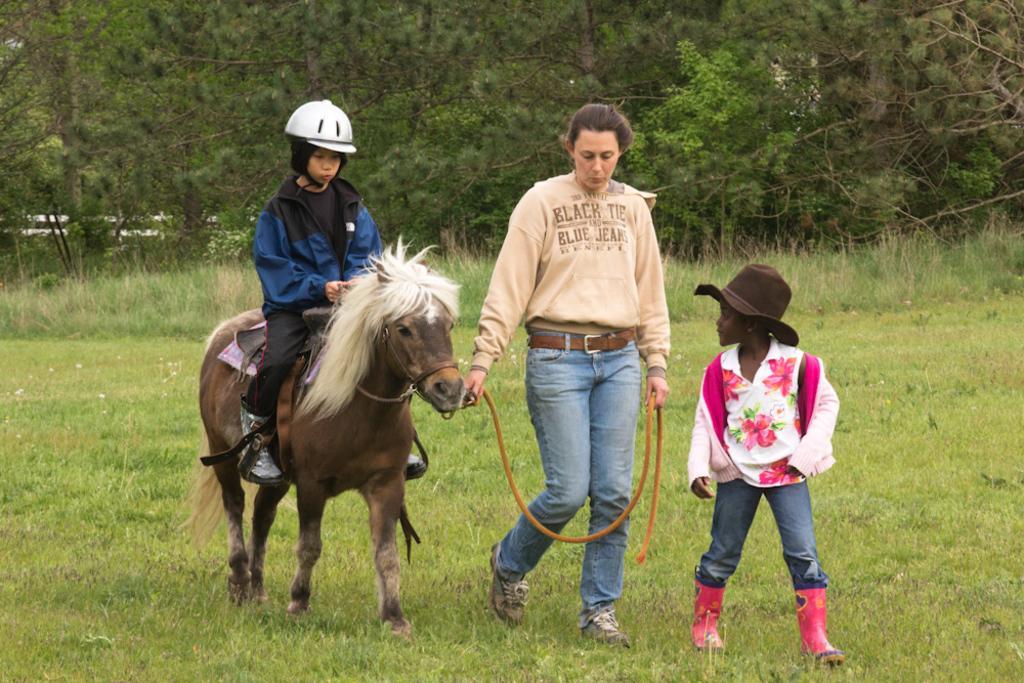Describe this image in one or two sentences. In this picture there are three person. Left person sitting on a horse and wears a helmet. Middle person holds a rope which is connected to the horse neck. And the right person wears a hut. And the background there are group of trees. Here it's a grass. 